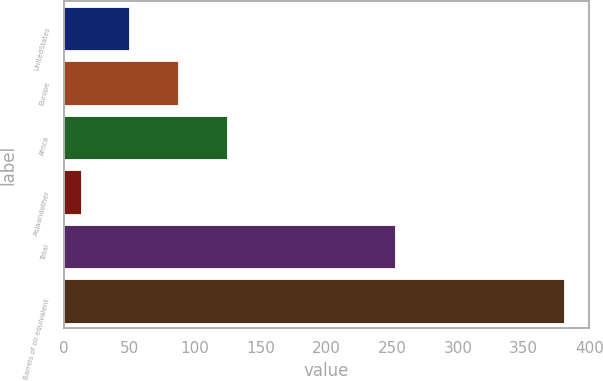<chart> <loc_0><loc_0><loc_500><loc_500><bar_chart><fcel>UnitedStates<fcel>Europe<fcel>Africa<fcel>Asiaandother<fcel>Total<fcel>Barrels of oil equivalent<nl><fcel>49.8<fcel>86.6<fcel>124<fcel>13<fcel>252<fcel>381<nl></chart> 